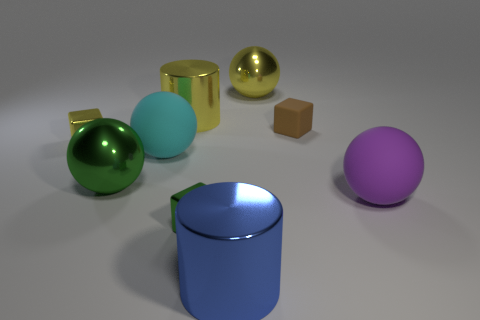Subtract all cylinders. How many objects are left? 7 Subtract all small yellow metal cubes. Subtract all large blue metal objects. How many objects are left? 7 Add 5 large yellow cylinders. How many large yellow cylinders are left? 6 Add 4 blocks. How many blocks exist? 7 Subtract 0 gray spheres. How many objects are left? 9 